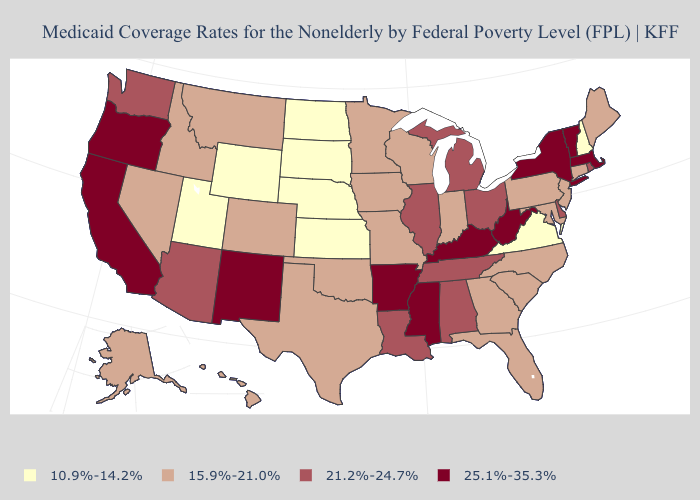Does Ohio have the same value as New Hampshire?
Answer briefly. No. Does Florida have the highest value in the South?
Give a very brief answer. No. Does the first symbol in the legend represent the smallest category?
Answer briefly. Yes. Does the first symbol in the legend represent the smallest category?
Keep it brief. Yes. What is the value of California?
Concise answer only. 25.1%-35.3%. Name the states that have a value in the range 21.2%-24.7%?
Short answer required. Alabama, Arizona, Delaware, Illinois, Louisiana, Michigan, Ohio, Rhode Island, Tennessee, Washington. Does Illinois have a lower value than New Mexico?
Write a very short answer. Yes. Does Arkansas have the same value as New York?
Quick response, please. Yes. What is the lowest value in the USA?
Write a very short answer. 10.9%-14.2%. What is the lowest value in states that border Maine?
Answer briefly. 10.9%-14.2%. Does Oregon have the highest value in the USA?
Be succinct. Yes. Name the states that have a value in the range 21.2%-24.7%?
Short answer required. Alabama, Arizona, Delaware, Illinois, Louisiana, Michigan, Ohio, Rhode Island, Tennessee, Washington. Among the states that border Montana , which have the lowest value?
Quick response, please. North Dakota, South Dakota, Wyoming. Among the states that border North Carolina , does Tennessee have the highest value?
Keep it brief. Yes. Does Illinois have a lower value than New Hampshire?
Be succinct. No. 